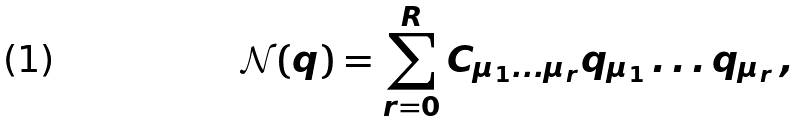Convert formula to latex. <formula><loc_0><loc_0><loc_500><loc_500>\mathcal { N } ( q ) = \sum _ { r = 0 } ^ { R } C _ { \mu _ { 1 } \dots \mu _ { r } } q _ { \mu _ { 1 } } \dots q _ { \mu _ { r } } \, ,</formula> 